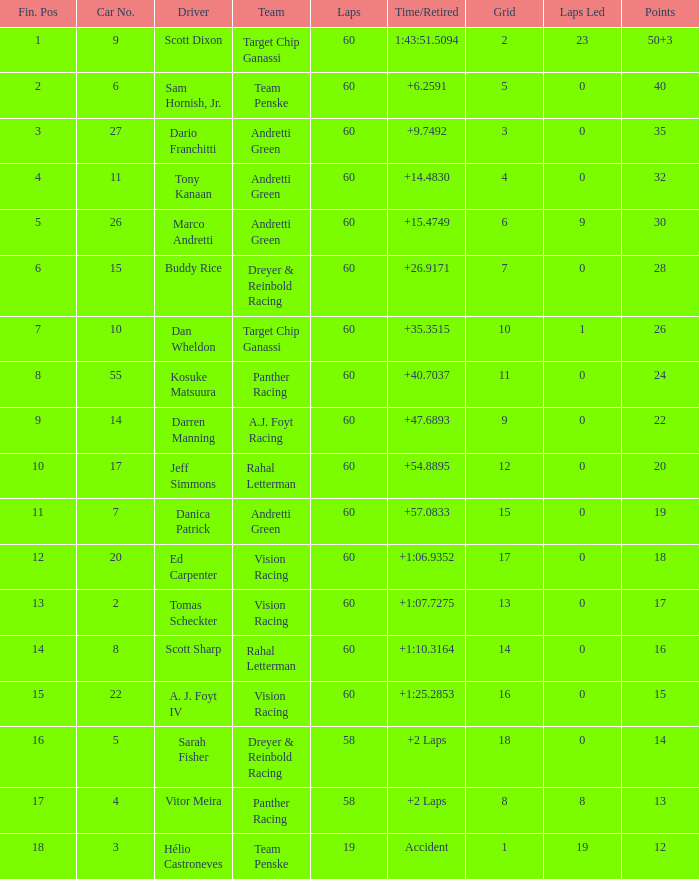Name the total number of grid for 30 1.0. 